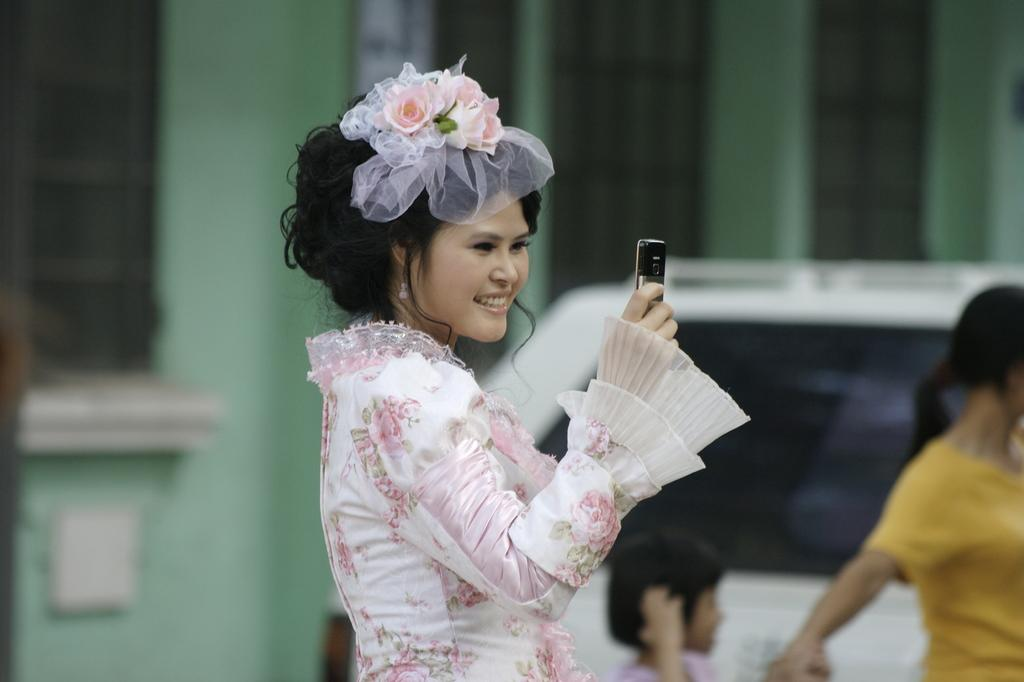Who is the main subject in the image? There is a woman in the image. What is the woman doing in the image? The woman is standing in the image. What object is the woman holding in her hand? The woman is holding a mobile phone in her hand. What type of lunch is the woman eating in the image? There is no lunch present in the image; the woman is holding a mobile phone. What class is the woman attending in the image? There is no indication of a class or educational setting in the image. 